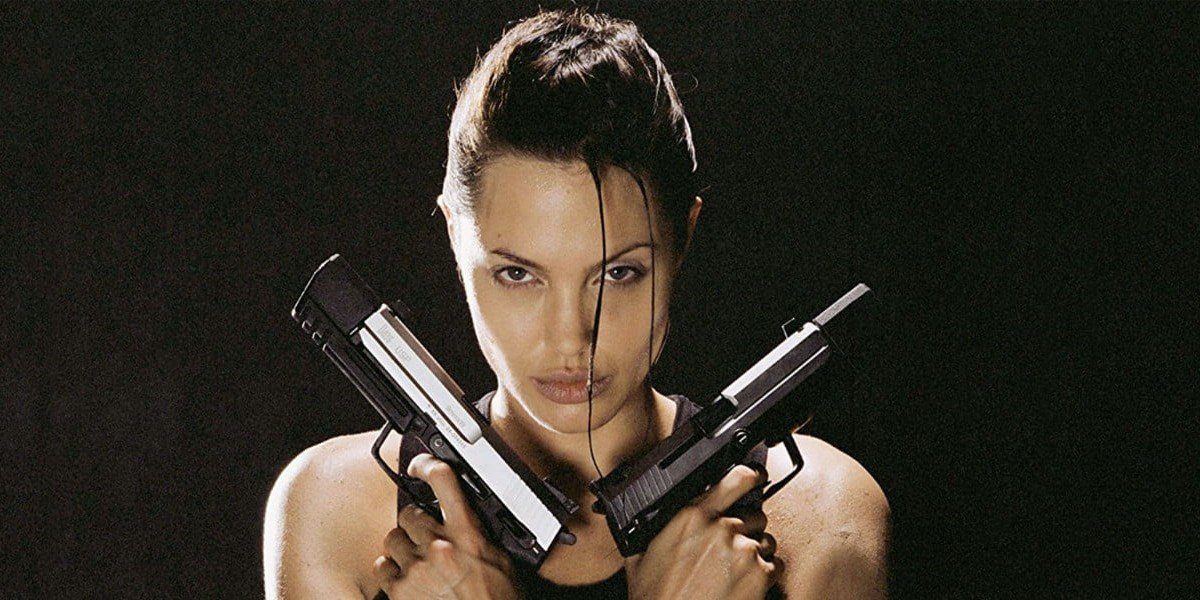How has Lara Croft's character evolved across the different 'Tomb Raider' films and games? Lara Croft, initially introduced in the video game series in 1996, has undergone significant transformations across the 'Tomb Raider' franchise both in films and games. Initially portrayed as a more one-dimensional adventurer, her character has been deeply developed to portray vulnerability, intelligence, and emotional depth. The evolution involves more realistic physical portrayals and complex story arcs that explore her motivations, personal history, and growth into a mature and formidable adventurer. The films, including Angelina Jolie's depiction, helped popularize this complex narrative, adding cinematic depth to her character's adventurous spirit and resilience. 